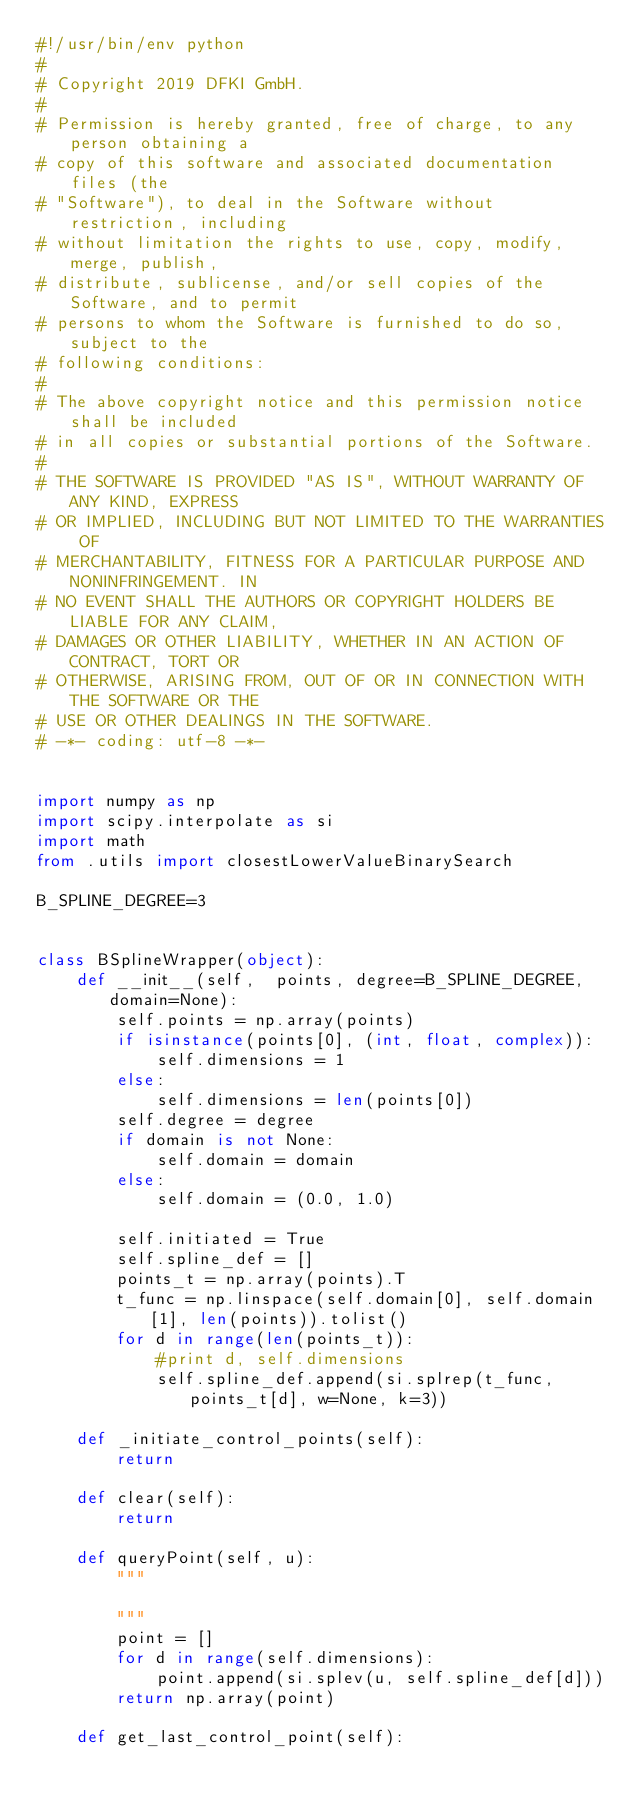<code> <loc_0><loc_0><loc_500><loc_500><_Python_>#!/usr/bin/env python
#
# Copyright 2019 DFKI GmbH.
#
# Permission is hereby granted, free of charge, to any person obtaining a
# copy of this software and associated documentation files (the
# "Software"), to deal in the Software without restriction, including
# without limitation the rights to use, copy, modify, merge, publish,
# distribute, sublicense, and/or sell copies of the Software, and to permit
# persons to whom the Software is furnished to do so, subject to the
# following conditions:
#
# The above copyright notice and this permission notice shall be included
# in all copies or substantial portions of the Software.
#
# THE SOFTWARE IS PROVIDED "AS IS", WITHOUT WARRANTY OF ANY KIND, EXPRESS
# OR IMPLIED, INCLUDING BUT NOT LIMITED TO THE WARRANTIES OF
# MERCHANTABILITY, FITNESS FOR A PARTICULAR PURPOSE AND NONINFRINGEMENT. IN
# NO EVENT SHALL THE AUTHORS OR COPYRIGHT HOLDERS BE LIABLE FOR ANY CLAIM,
# DAMAGES OR OTHER LIABILITY, WHETHER IN AN ACTION OF CONTRACT, TORT OR
# OTHERWISE, ARISING FROM, OUT OF OR IN CONNECTION WITH THE SOFTWARE OR THE
# USE OR OTHER DEALINGS IN THE SOFTWARE.
# -*- coding: utf-8 -*-


import numpy as np
import scipy.interpolate as si
import math
from .utils import closestLowerValueBinarySearch
    
B_SPLINE_DEGREE=3


class BSplineWrapper(object):
    def __init__(self,  points, degree=B_SPLINE_DEGREE, domain=None):
        self.points = np.array(points)
        if isinstance(points[0], (int, float, complex)):
            self.dimensions = 1
        else:
            self.dimensions = len(points[0])
        self.degree = degree
        if domain is not None:
            self.domain = domain
        else:
            self.domain = (0.0, 1.0)
 
        self.initiated = True
        self.spline_def = []
        points_t = np.array(points).T
        t_func = np.linspace(self.domain[0], self.domain[1], len(points)).tolist()
        for d in range(len(points_t)):
            #print d, self.dimensions
            self.spline_def.append(si.splrep(t_func, points_t[d], w=None, k=3))

    def _initiate_control_points(self):
        return

    def clear(self):
        return

    def queryPoint(self, u):
        """

        """
        point = []
        for d in range(self.dimensions):
            point.append(si.splev(u, self.spline_def[d]))
        return np.array(point)

    def get_last_control_point(self):</code> 